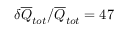<formula> <loc_0><loc_0><loc_500><loc_500>\delta \overline { Q } _ { t o t } / \overline { Q } _ { t o t } = 4 7 \, \</formula> 